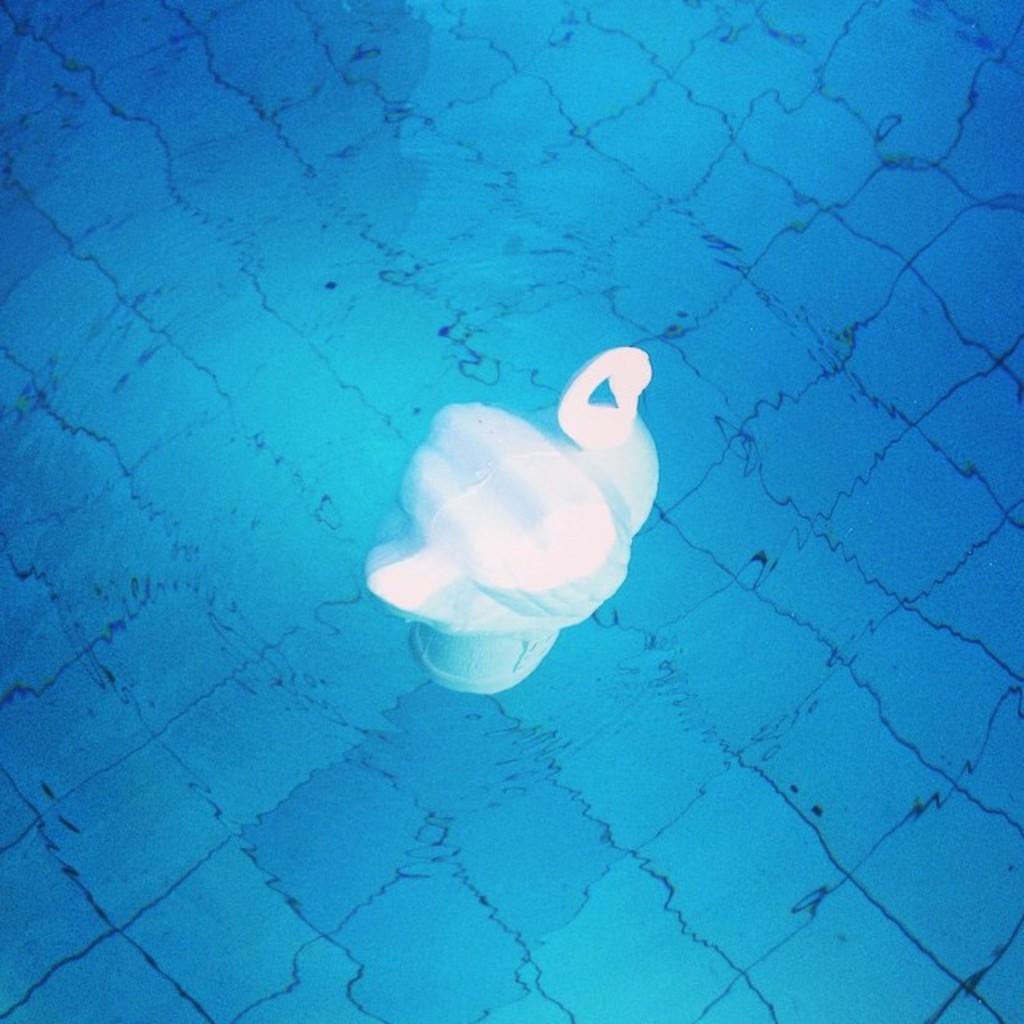Could you give a brief overview of what you see in this image? In this image we can see depiction of a swan in water. 